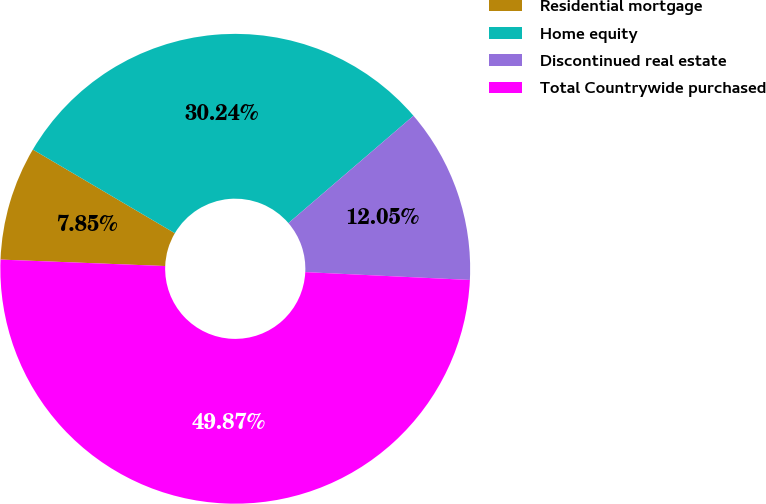Convert chart. <chart><loc_0><loc_0><loc_500><loc_500><pie_chart><fcel>Residential mortgage<fcel>Home equity<fcel>Discontinued real estate<fcel>Total Countrywide purchased<nl><fcel>7.85%<fcel>30.24%<fcel>12.05%<fcel>49.87%<nl></chart> 